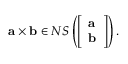<formula> <loc_0><loc_0><loc_500><loc_500>a \times b \in N S \left ( { \left [ \begin{array} { l } { a } \\ { b } \end{array} \right ] } \right ) .</formula> 